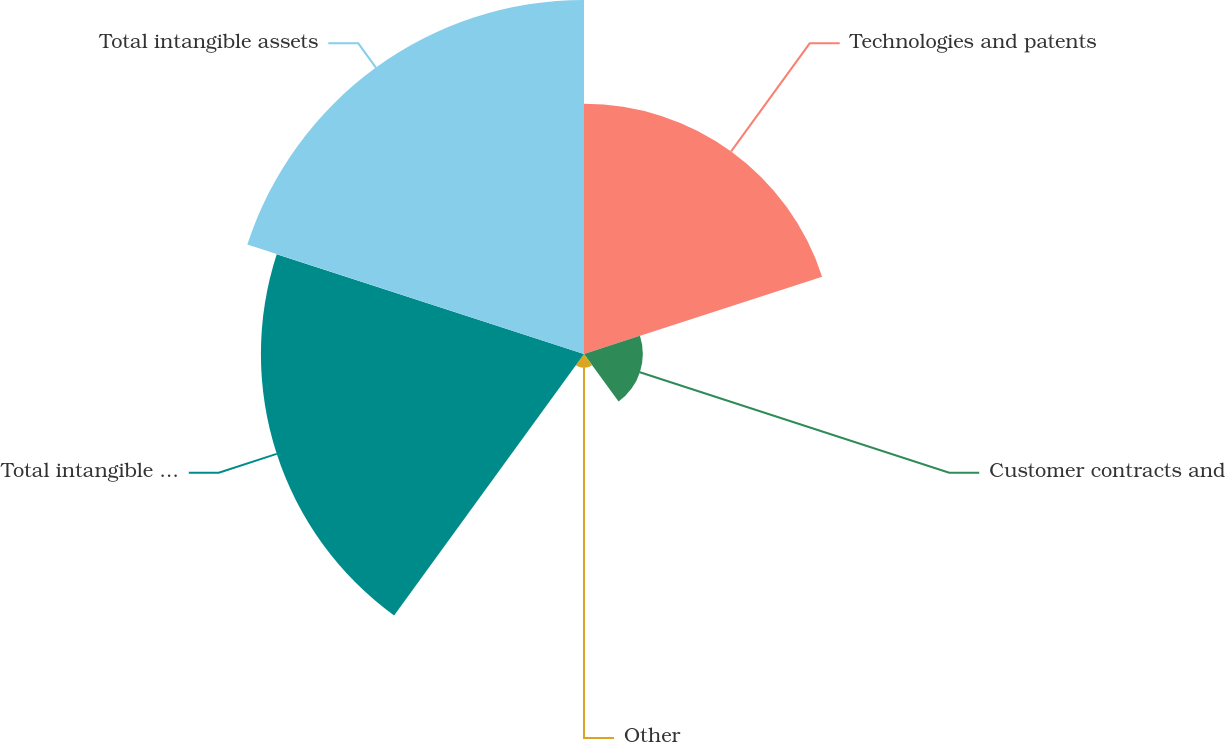<chart> <loc_0><loc_0><loc_500><loc_500><pie_chart><fcel>Technologies and patents<fcel>Customer contracts and<fcel>Other<fcel>Total intangible with finite<fcel>Total intangible assets<nl><fcel>25.03%<fcel>5.88%<fcel>1.4%<fcel>32.3%<fcel>35.39%<nl></chart> 